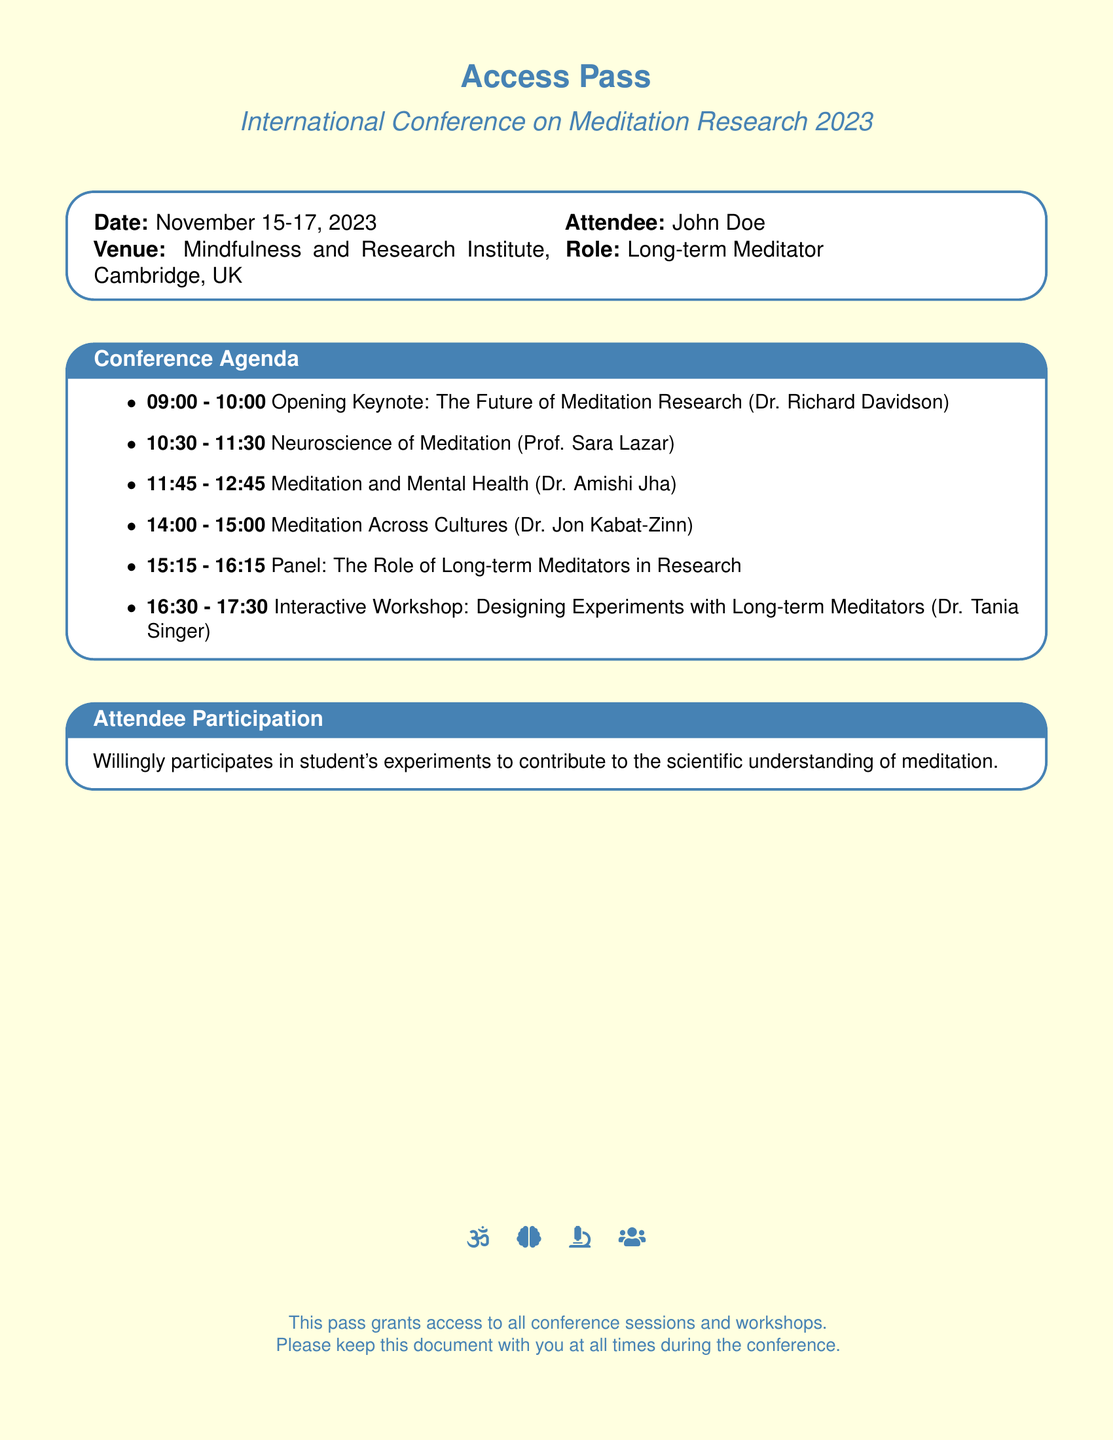What is the date of the conference? The date of the conference is explicitly stated in the document under the agenda section.
Answer: November 15-17, 2023 Who is the opening keynote speaker? The opening keynote speaker is mentioned in the agenda part of the document.
Answer: Dr. Richard Davidson What role does the attendee have? The role of the attendee is clearly specified in the attendee section of the document.
Answer: Long-term Meditator What is the venue for the conference? The venue is provided in the document and is crucial for attendees to know its location.
Answer: Mindfulness and Research Institute, Cambridge, UK What time does the panel discussion start? The time for the panel discussion is included in the agenda and critical for scheduling.
Answer: 15:15 Which workshop is focused on experimental design? The specific workshop mentioned in the agenda deals with designing experiments involving a unique aspect.
Answer: Interactive Workshop: Designing Experiments with Long-term Meditators How many sessions are there on the first day? The number of sessions on the first day can be deduced from the agenda.
Answer: 5 Does the pass grant access to all sessions? The document concludes with information about the access granted by the pass, reflecting its comprehensive nature.
Answer: Yes 